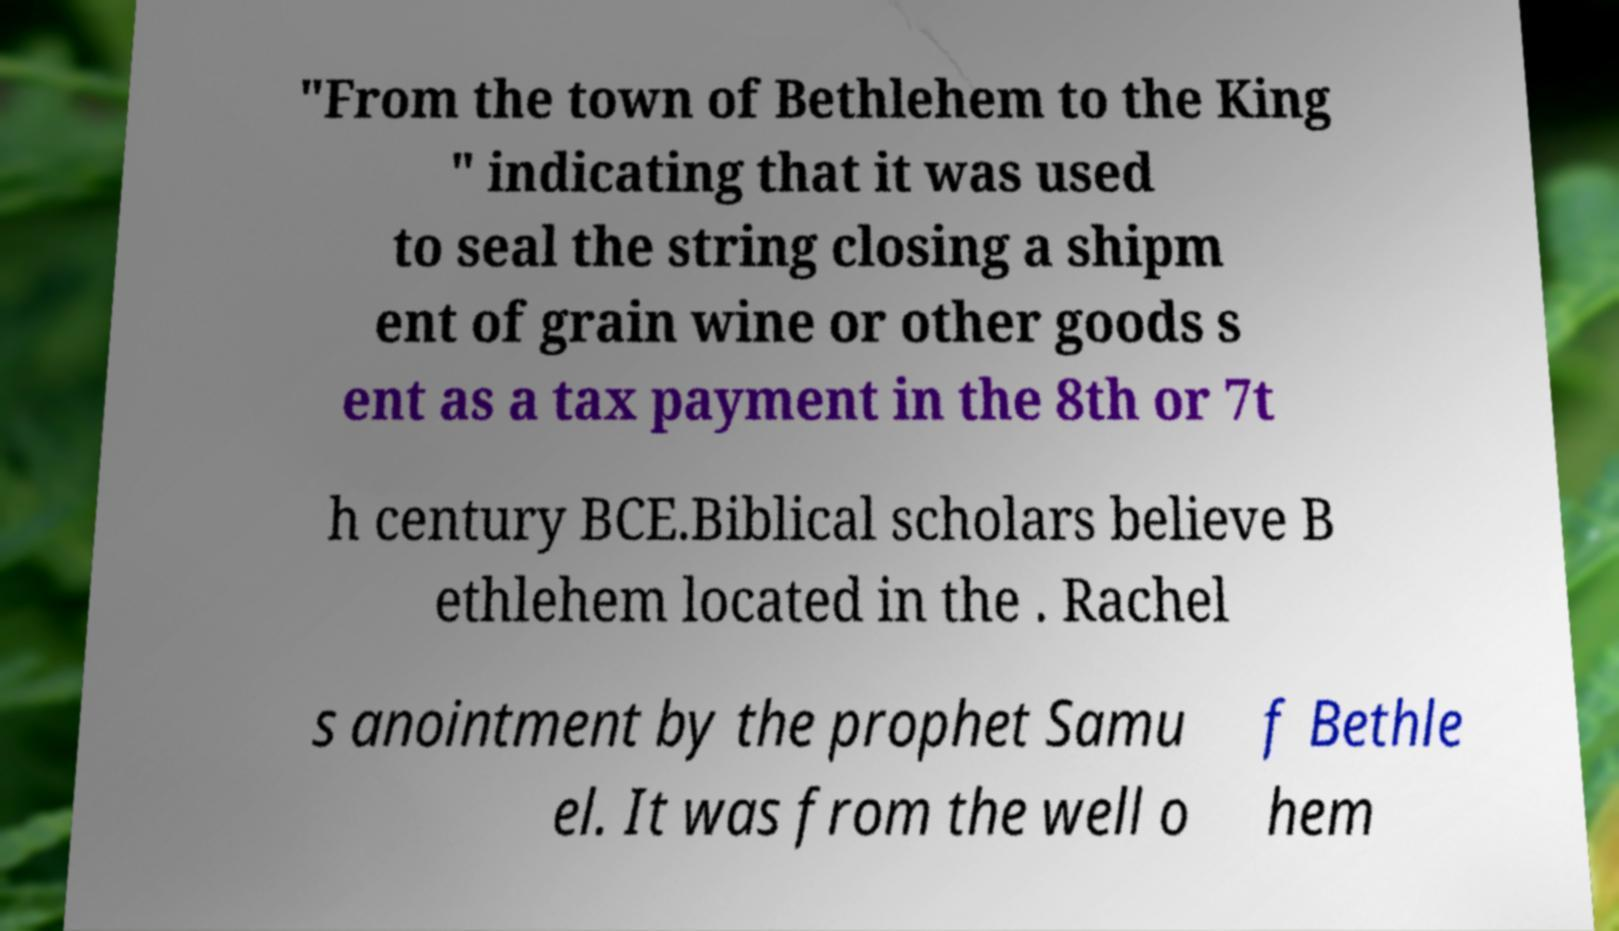What messages or text are displayed in this image? I need them in a readable, typed format. "From the town of Bethlehem to the King " indicating that it was used to seal the string closing a shipm ent of grain wine or other goods s ent as a tax payment in the 8th or 7t h century BCE.Biblical scholars believe B ethlehem located in the . Rachel s anointment by the prophet Samu el. It was from the well o f Bethle hem 